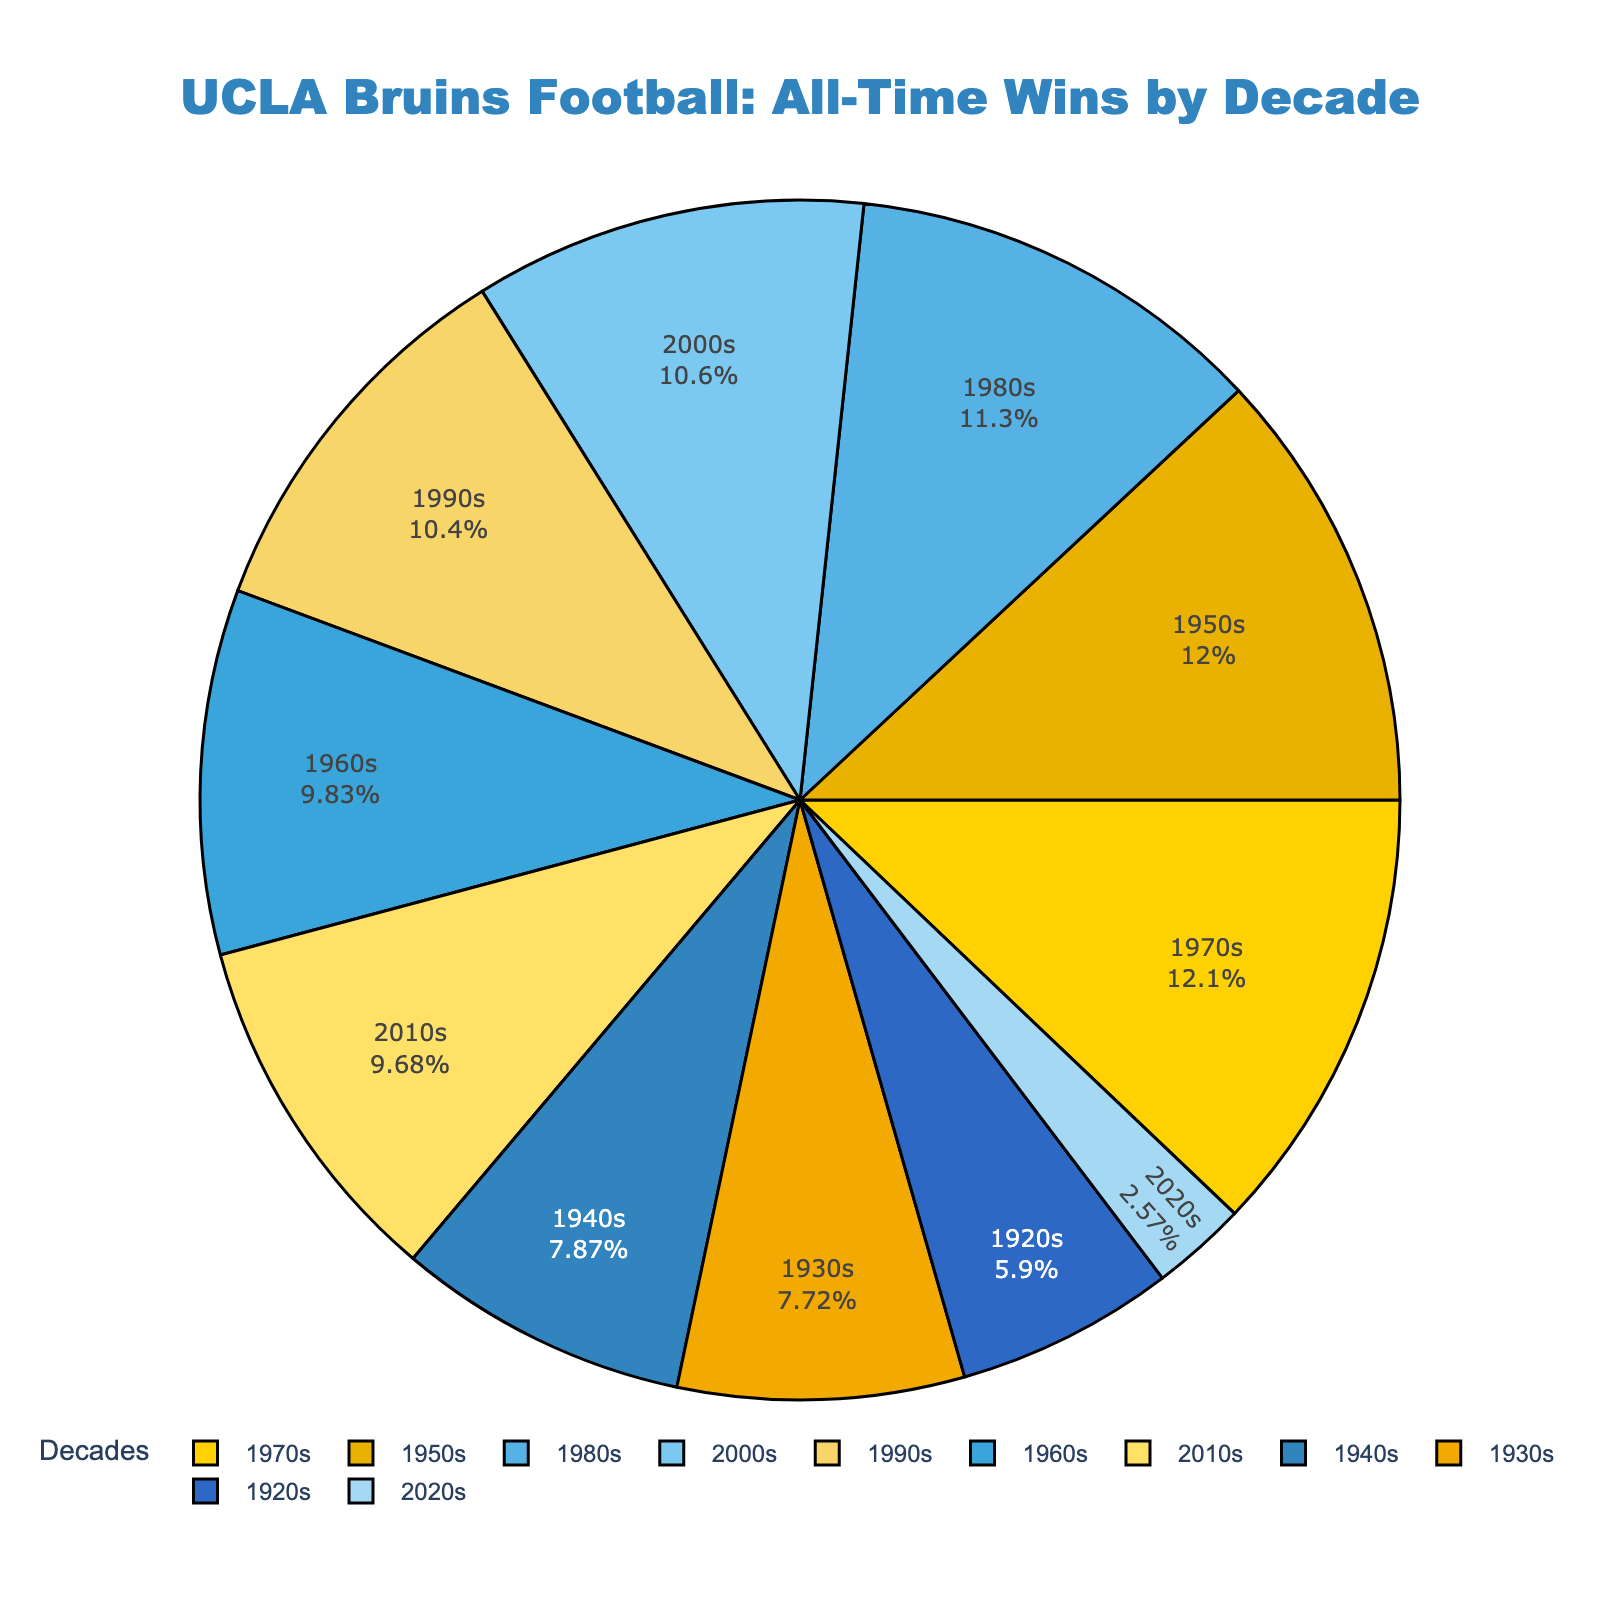What's the decade with the highest number of wins? The decade with the highest number of wins can be identified by finding the largest segment in the pie chart. The 1970s have the highest number of wins.
Answer: 1970s Which decade had more wins, the 1980s or the 1990s? To find out which decade had more wins, we need to compare the segments for the 1980s and 1990s in the pie chart. The 1980s had 75 wins, while the 1990s had 69 wins.
Answer: 1980s What is the total number of wins for decades before the 1950s? Adding the wins from the 1920s, 1930s, and 1940s gives us the total wins before the 1950s: 39 + 51 + 52 = 142
Answer: 142 What percentage of the total wins did the 1970s contribute? The pie chart provides the percentage. By looking at the segment labeled '1970s', it can be observed that it corresponds to approximately 13.3%.
Answer: 13.3% How many more wins did the 1950s have compared to the 2020s? Subtracting the wins in the 2020s from the wins in the 1950s gives us the difference: 79 - 17 = 62
Answer: 62 Between the 2000s and 2010s, which decade had fewer wins, and by how much? To find out which decade had fewer wins and by how much, we compare the wins in the 2000s (70) and 2010s (64). The 2010s had fewer wins by 70 - 64 = 6 wins.
Answer: 2010s, 6 What is the contribution of wins in the 1960s to the total wins across all decades? Calculate the percentage of wins in the 1960s out of the total: (65 / (39+51+52+79+65+80+75+69+70+64+17)) * 100 ≈ 10.8%
Answer: 10.8% Arrange the following decades in descending order by wins: 1940s, 1950s, 1960s. Compare the number of wins for each decade: 1950s (79), 1960s (65), 1940s (52). Sorting them gives us: 1950s, 1960s, 1940s
Answer: 1950s, 1960s, 1940s What's the difference in the number of wins between the 1920s and 1930s? Subtract the wins in the 1920s from the wins in the 1930s: 51 - 39 = 12
Answer: 12 Which decades hold the second and third highest number of wins? First, identify the highest win decade, which is the 1970s with 80 wins. The next highest is the 1950s with 79, followed by the 1980s with 75. Thus, the second and third highest are the 1950s and 1980s respectively.
Answer: 1950s, 1980s 